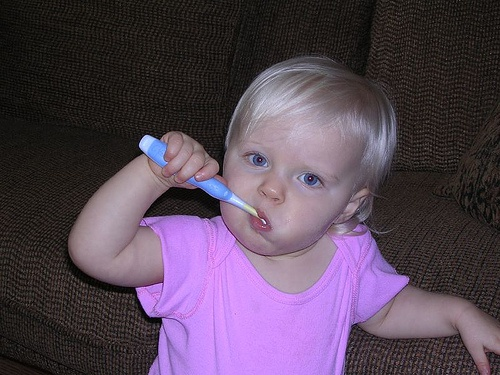Describe the objects in this image and their specific colors. I can see couch in black and gray tones, people in black, darkgray, violet, and gray tones, and toothbrush in black, lightblue, lavender, and gray tones in this image. 